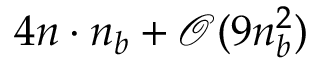Convert formula to latex. <formula><loc_0><loc_0><loc_500><loc_500>4 n \cdot n _ { b } + \mathcal { O } ( 9 n _ { b } ^ { 2 } )</formula> 